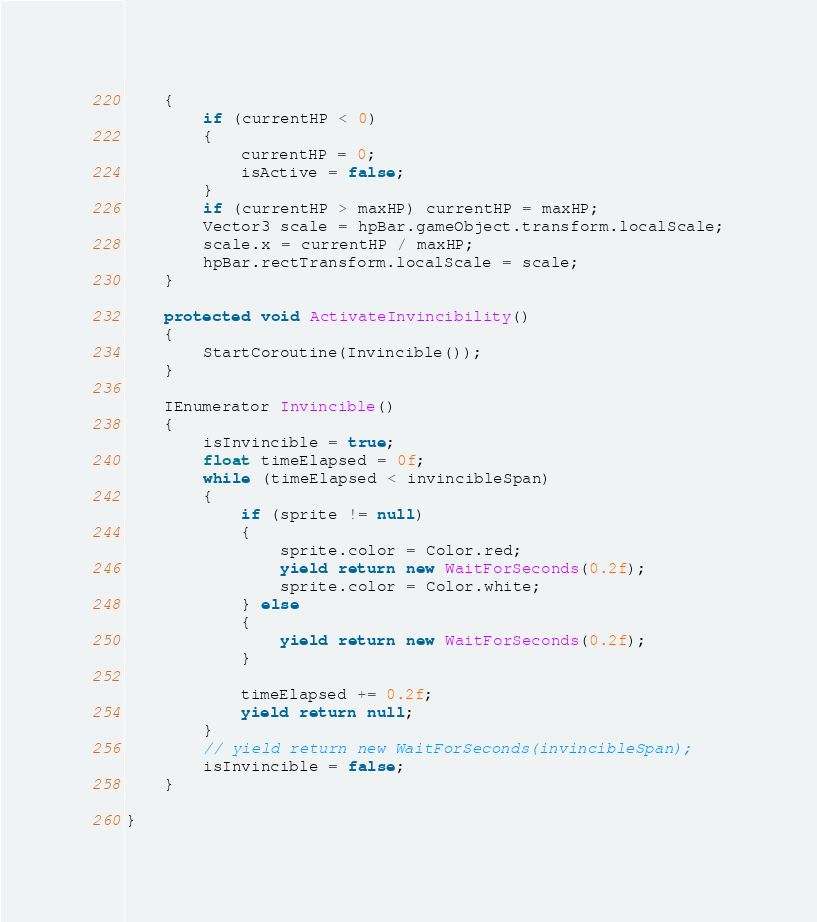Convert code to text. <code><loc_0><loc_0><loc_500><loc_500><_C#_>    {
        if (currentHP < 0)
        {
            currentHP = 0;
            isActive = false;
        }
        if (currentHP > maxHP) currentHP = maxHP;
        Vector3 scale = hpBar.gameObject.transform.localScale;
        scale.x = currentHP / maxHP;
        hpBar.rectTransform.localScale = scale;
    }

    protected void ActivateInvincibility()
    {
        StartCoroutine(Invincible());
    }

    IEnumerator Invincible()
    {
        isInvincible = true;
        float timeElapsed = 0f;
        while (timeElapsed < invincibleSpan)
        {
            if (sprite != null)
            {
                sprite.color = Color.red;
                yield return new WaitForSeconds(0.2f);
                sprite.color = Color.white;
            } else
            {
                yield return new WaitForSeconds(0.2f);
            }
            
            timeElapsed += 0.2f;
            yield return null;
        }
        // yield return new WaitForSeconds(invincibleSpan);
        isInvincible = false;
    }

}
</code> 